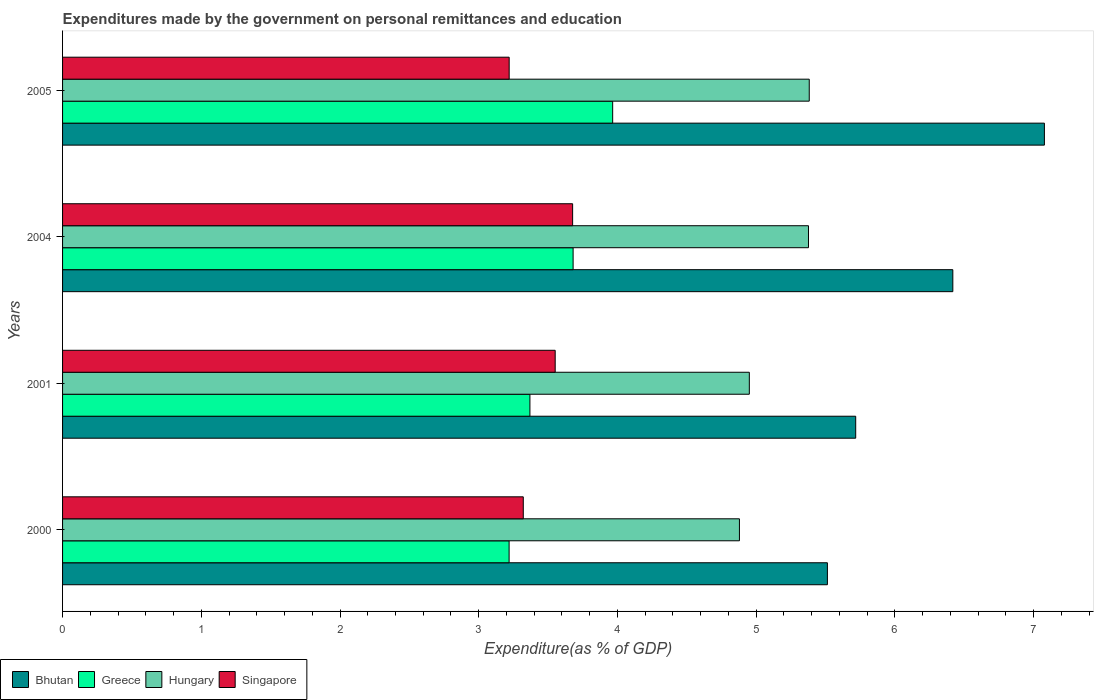How many different coloured bars are there?
Provide a short and direct response. 4. What is the label of the 1st group of bars from the top?
Offer a terse response. 2005. In how many cases, is the number of bars for a given year not equal to the number of legend labels?
Make the answer very short. 0. What is the expenditures made by the government on personal remittances and education in Singapore in 2004?
Give a very brief answer. 3.68. Across all years, what is the maximum expenditures made by the government on personal remittances and education in Greece?
Ensure brevity in your answer.  3.97. Across all years, what is the minimum expenditures made by the government on personal remittances and education in Greece?
Offer a terse response. 3.22. In which year was the expenditures made by the government on personal remittances and education in Singapore maximum?
Make the answer very short. 2004. In which year was the expenditures made by the government on personal remittances and education in Bhutan minimum?
Offer a very short reply. 2000. What is the total expenditures made by the government on personal remittances and education in Hungary in the graph?
Your answer should be compact. 20.59. What is the difference between the expenditures made by the government on personal remittances and education in Hungary in 2000 and that in 2005?
Offer a terse response. -0.5. What is the difference between the expenditures made by the government on personal remittances and education in Singapore in 2004 and the expenditures made by the government on personal remittances and education in Hungary in 2005?
Provide a short and direct response. -1.71. What is the average expenditures made by the government on personal remittances and education in Hungary per year?
Keep it short and to the point. 5.15. In the year 2000, what is the difference between the expenditures made by the government on personal remittances and education in Bhutan and expenditures made by the government on personal remittances and education in Greece?
Provide a short and direct response. 2.29. What is the ratio of the expenditures made by the government on personal remittances and education in Hungary in 2000 to that in 2005?
Provide a succinct answer. 0.91. Is the expenditures made by the government on personal remittances and education in Singapore in 2004 less than that in 2005?
Your answer should be compact. No. Is the difference between the expenditures made by the government on personal remittances and education in Bhutan in 2004 and 2005 greater than the difference between the expenditures made by the government on personal remittances and education in Greece in 2004 and 2005?
Make the answer very short. No. What is the difference between the highest and the second highest expenditures made by the government on personal remittances and education in Greece?
Your response must be concise. 0.29. What is the difference between the highest and the lowest expenditures made by the government on personal remittances and education in Greece?
Make the answer very short. 0.75. Is the sum of the expenditures made by the government on personal remittances and education in Singapore in 2000 and 2005 greater than the maximum expenditures made by the government on personal remittances and education in Bhutan across all years?
Offer a very short reply. No. What does the 2nd bar from the top in 2000 represents?
Make the answer very short. Hungary. What does the 1st bar from the bottom in 2005 represents?
Keep it short and to the point. Bhutan. Is it the case that in every year, the sum of the expenditures made by the government on personal remittances and education in Greece and expenditures made by the government on personal remittances and education in Hungary is greater than the expenditures made by the government on personal remittances and education in Bhutan?
Provide a short and direct response. Yes. Are all the bars in the graph horizontal?
Ensure brevity in your answer.  Yes. What is the difference between two consecutive major ticks on the X-axis?
Make the answer very short. 1. Are the values on the major ticks of X-axis written in scientific E-notation?
Offer a very short reply. No. Does the graph contain any zero values?
Make the answer very short. No. Where does the legend appear in the graph?
Ensure brevity in your answer.  Bottom left. What is the title of the graph?
Provide a succinct answer. Expenditures made by the government on personal remittances and education. What is the label or title of the X-axis?
Offer a terse response. Expenditure(as % of GDP). What is the label or title of the Y-axis?
Your answer should be very brief. Years. What is the Expenditure(as % of GDP) in Bhutan in 2000?
Give a very brief answer. 5.51. What is the Expenditure(as % of GDP) of Greece in 2000?
Keep it short and to the point. 3.22. What is the Expenditure(as % of GDP) of Hungary in 2000?
Give a very brief answer. 4.88. What is the Expenditure(as % of GDP) in Singapore in 2000?
Offer a very short reply. 3.32. What is the Expenditure(as % of GDP) in Bhutan in 2001?
Provide a short and direct response. 5.72. What is the Expenditure(as % of GDP) of Greece in 2001?
Offer a very short reply. 3.37. What is the Expenditure(as % of GDP) of Hungary in 2001?
Provide a short and direct response. 4.95. What is the Expenditure(as % of GDP) of Singapore in 2001?
Your answer should be compact. 3.55. What is the Expenditure(as % of GDP) of Bhutan in 2004?
Offer a very short reply. 6.42. What is the Expenditure(as % of GDP) of Greece in 2004?
Provide a short and direct response. 3.68. What is the Expenditure(as % of GDP) in Hungary in 2004?
Your answer should be compact. 5.38. What is the Expenditure(as % of GDP) of Singapore in 2004?
Keep it short and to the point. 3.68. What is the Expenditure(as % of GDP) in Bhutan in 2005?
Offer a terse response. 7.08. What is the Expenditure(as % of GDP) of Greece in 2005?
Provide a short and direct response. 3.97. What is the Expenditure(as % of GDP) of Hungary in 2005?
Give a very brief answer. 5.38. What is the Expenditure(as % of GDP) in Singapore in 2005?
Offer a very short reply. 3.22. Across all years, what is the maximum Expenditure(as % of GDP) in Bhutan?
Provide a short and direct response. 7.08. Across all years, what is the maximum Expenditure(as % of GDP) of Greece?
Offer a very short reply. 3.97. Across all years, what is the maximum Expenditure(as % of GDP) in Hungary?
Your answer should be very brief. 5.38. Across all years, what is the maximum Expenditure(as % of GDP) of Singapore?
Provide a succinct answer. 3.68. Across all years, what is the minimum Expenditure(as % of GDP) of Bhutan?
Ensure brevity in your answer.  5.51. Across all years, what is the minimum Expenditure(as % of GDP) in Greece?
Your answer should be compact. 3.22. Across all years, what is the minimum Expenditure(as % of GDP) of Hungary?
Your response must be concise. 4.88. Across all years, what is the minimum Expenditure(as % of GDP) of Singapore?
Ensure brevity in your answer.  3.22. What is the total Expenditure(as % of GDP) of Bhutan in the graph?
Your response must be concise. 24.73. What is the total Expenditure(as % of GDP) of Greece in the graph?
Your answer should be very brief. 14.23. What is the total Expenditure(as % of GDP) of Hungary in the graph?
Ensure brevity in your answer.  20.59. What is the total Expenditure(as % of GDP) of Singapore in the graph?
Offer a very short reply. 13.77. What is the difference between the Expenditure(as % of GDP) of Bhutan in 2000 and that in 2001?
Provide a succinct answer. -0.2. What is the difference between the Expenditure(as % of GDP) of Hungary in 2000 and that in 2001?
Offer a terse response. -0.07. What is the difference between the Expenditure(as % of GDP) of Singapore in 2000 and that in 2001?
Make the answer very short. -0.23. What is the difference between the Expenditure(as % of GDP) of Bhutan in 2000 and that in 2004?
Your answer should be very brief. -0.9. What is the difference between the Expenditure(as % of GDP) in Greece in 2000 and that in 2004?
Make the answer very short. -0.46. What is the difference between the Expenditure(as % of GDP) of Hungary in 2000 and that in 2004?
Ensure brevity in your answer.  -0.5. What is the difference between the Expenditure(as % of GDP) in Singapore in 2000 and that in 2004?
Provide a succinct answer. -0.36. What is the difference between the Expenditure(as % of GDP) in Bhutan in 2000 and that in 2005?
Your response must be concise. -1.56. What is the difference between the Expenditure(as % of GDP) in Greece in 2000 and that in 2005?
Provide a short and direct response. -0.75. What is the difference between the Expenditure(as % of GDP) of Hungary in 2000 and that in 2005?
Your answer should be very brief. -0.5. What is the difference between the Expenditure(as % of GDP) of Singapore in 2000 and that in 2005?
Offer a very short reply. 0.1. What is the difference between the Expenditure(as % of GDP) of Bhutan in 2001 and that in 2004?
Offer a very short reply. -0.7. What is the difference between the Expenditure(as % of GDP) of Greece in 2001 and that in 2004?
Offer a terse response. -0.31. What is the difference between the Expenditure(as % of GDP) in Hungary in 2001 and that in 2004?
Offer a very short reply. -0.43. What is the difference between the Expenditure(as % of GDP) of Singapore in 2001 and that in 2004?
Provide a short and direct response. -0.13. What is the difference between the Expenditure(as % of GDP) of Bhutan in 2001 and that in 2005?
Your answer should be very brief. -1.36. What is the difference between the Expenditure(as % of GDP) in Greece in 2001 and that in 2005?
Your answer should be very brief. -0.6. What is the difference between the Expenditure(as % of GDP) of Hungary in 2001 and that in 2005?
Your answer should be compact. -0.43. What is the difference between the Expenditure(as % of GDP) of Singapore in 2001 and that in 2005?
Give a very brief answer. 0.33. What is the difference between the Expenditure(as % of GDP) of Bhutan in 2004 and that in 2005?
Your answer should be compact. -0.66. What is the difference between the Expenditure(as % of GDP) in Greece in 2004 and that in 2005?
Your answer should be very brief. -0.29. What is the difference between the Expenditure(as % of GDP) of Hungary in 2004 and that in 2005?
Provide a succinct answer. -0.01. What is the difference between the Expenditure(as % of GDP) of Singapore in 2004 and that in 2005?
Keep it short and to the point. 0.46. What is the difference between the Expenditure(as % of GDP) of Bhutan in 2000 and the Expenditure(as % of GDP) of Greece in 2001?
Provide a short and direct response. 2.14. What is the difference between the Expenditure(as % of GDP) of Bhutan in 2000 and the Expenditure(as % of GDP) of Hungary in 2001?
Your answer should be compact. 0.56. What is the difference between the Expenditure(as % of GDP) of Bhutan in 2000 and the Expenditure(as % of GDP) of Singapore in 2001?
Offer a very short reply. 1.96. What is the difference between the Expenditure(as % of GDP) in Greece in 2000 and the Expenditure(as % of GDP) in Hungary in 2001?
Your answer should be compact. -1.73. What is the difference between the Expenditure(as % of GDP) of Greece in 2000 and the Expenditure(as % of GDP) of Singapore in 2001?
Offer a terse response. -0.33. What is the difference between the Expenditure(as % of GDP) in Hungary in 2000 and the Expenditure(as % of GDP) in Singapore in 2001?
Provide a succinct answer. 1.33. What is the difference between the Expenditure(as % of GDP) in Bhutan in 2000 and the Expenditure(as % of GDP) in Greece in 2004?
Provide a succinct answer. 1.83. What is the difference between the Expenditure(as % of GDP) in Bhutan in 2000 and the Expenditure(as % of GDP) in Hungary in 2004?
Provide a succinct answer. 0.14. What is the difference between the Expenditure(as % of GDP) of Bhutan in 2000 and the Expenditure(as % of GDP) of Singapore in 2004?
Your response must be concise. 1.84. What is the difference between the Expenditure(as % of GDP) of Greece in 2000 and the Expenditure(as % of GDP) of Hungary in 2004?
Make the answer very short. -2.16. What is the difference between the Expenditure(as % of GDP) in Greece in 2000 and the Expenditure(as % of GDP) in Singapore in 2004?
Make the answer very short. -0.46. What is the difference between the Expenditure(as % of GDP) of Hungary in 2000 and the Expenditure(as % of GDP) of Singapore in 2004?
Keep it short and to the point. 1.2. What is the difference between the Expenditure(as % of GDP) of Bhutan in 2000 and the Expenditure(as % of GDP) of Greece in 2005?
Your answer should be compact. 1.55. What is the difference between the Expenditure(as % of GDP) in Bhutan in 2000 and the Expenditure(as % of GDP) in Hungary in 2005?
Your response must be concise. 0.13. What is the difference between the Expenditure(as % of GDP) of Bhutan in 2000 and the Expenditure(as % of GDP) of Singapore in 2005?
Provide a short and direct response. 2.29. What is the difference between the Expenditure(as % of GDP) in Greece in 2000 and the Expenditure(as % of GDP) in Hungary in 2005?
Make the answer very short. -2.16. What is the difference between the Expenditure(as % of GDP) of Greece in 2000 and the Expenditure(as % of GDP) of Singapore in 2005?
Provide a succinct answer. -0. What is the difference between the Expenditure(as % of GDP) in Hungary in 2000 and the Expenditure(as % of GDP) in Singapore in 2005?
Your answer should be compact. 1.66. What is the difference between the Expenditure(as % of GDP) in Bhutan in 2001 and the Expenditure(as % of GDP) in Greece in 2004?
Ensure brevity in your answer.  2.04. What is the difference between the Expenditure(as % of GDP) in Bhutan in 2001 and the Expenditure(as % of GDP) in Hungary in 2004?
Provide a succinct answer. 0.34. What is the difference between the Expenditure(as % of GDP) in Bhutan in 2001 and the Expenditure(as % of GDP) in Singapore in 2004?
Make the answer very short. 2.04. What is the difference between the Expenditure(as % of GDP) in Greece in 2001 and the Expenditure(as % of GDP) in Hungary in 2004?
Provide a short and direct response. -2.01. What is the difference between the Expenditure(as % of GDP) in Greece in 2001 and the Expenditure(as % of GDP) in Singapore in 2004?
Give a very brief answer. -0.31. What is the difference between the Expenditure(as % of GDP) in Hungary in 2001 and the Expenditure(as % of GDP) in Singapore in 2004?
Offer a very short reply. 1.27. What is the difference between the Expenditure(as % of GDP) of Bhutan in 2001 and the Expenditure(as % of GDP) of Greece in 2005?
Provide a succinct answer. 1.75. What is the difference between the Expenditure(as % of GDP) of Bhutan in 2001 and the Expenditure(as % of GDP) of Hungary in 2005?
Offer a very short reply. 0.33. What is the difference between the Expenditure(as % of GDP) of Bhutan in 2001 and the Expenditure(as % of GDP) of Singapore in 2005?
Your answer should be compact. 2.5. What is the difference between the Expenditure(as % of GDP) in Greece in 2001 and the Expenditure(as % of GDP) in Hungary in 2005?
Your response must be concise. -2.01. What is the difference between the Expenditure(as % of GDP) of Greece in 2001 and the Expenditure(as % of GDP) of Singapore in 2005?
Keep it short and to the point. 0.15. What is the difference between the Expenditure(as % of GDP) of Hungary in 2001 and the Expenditure(as % of GDP) of Singapore in 2005?
Provide a succinct answer. 1.73. What is the difference between the Expenditure(as % of GDP) of Bhutan in 2004 and the Expenditure(as % of GDP) of Greece in 2005?
Your response must be concise. 2.45. What is the difference between the Expenditure(as % of GDP) of Bhutan in 2004 and the Expenditure(as % of GDP) of Hungary in 2005?
Offer a very short reply. 1.04. What is the difference between the Expenditure(as % of GDP) of Bhutan in 2004 and the Expenditure(as % of GDP) of Singapore in 2005?
Your answer should be compact. 3.2. What is the difference between the Expenditure(as % of GDP) of Greece in 2004 and the Expenditure(as % of GDP) of Hungary in 2005?
Offer a terse response. -1.7. What is the difference between the Expenditure(as % of GDP) in Greece in 2004 and the Expenditure(as % of GDP) in Singapore in 2005?
Give a very brief answer. 0.46. What is the difference between the Expenditure(as % of GDP) in Hungary in 2004 and the Expenditure(as % of GDP) in Singapore in 2005?
Give a very brief answer. 2.16. What is the average Expenditure(as % of GDP) in Bhutan per year?
Keep it short and to the point. 6.18. What is the average Expenditure(as % of GDP) in Greece per year?
Your answer should be very brief. 3.56. What is the average Expenditure(as % of GDP) of Hungary per year?
Offer a very short reply. 5.15. What is the average Expenditure(as % of GDP) in Singapore per year?
Offer a terse response. 3.44. In the year 2000, what is the difference between the Expenditure(as % of GDP) of Bhutan and Expenditure(as % of GDP) of Greece?
Keep it short and to the point. 2.29. In the year 2000, what is the difference between the Expenditure(as % of GDP) in Bhutan and Expenditure(as % of GDP) in Hungary?
Make the answer very short. 0.63. In the year 2000, what is the difference between the Expenditure(as % of GDP) in Bhutan and Expenditure(as % of GDP) in Singapore?
Offer a terse response. 2.19. In the year 2000, what is the difference between the Expenditure(as % of GDP) of Greece and Expenditure(as % of GDP) of Hungary?
Your answer should be very brief. -1.66. In the year 2000, what is the difference between the Expenditure(as % of GDP) of Greece and Expenditure(as % of GDP) of Singapore?
Offer a terse response. -0.1. In the year 2000, what is the difference between the Expenditure(as % of GDP) of Hungary and Expenditure(as % of GDP) of Singapore?
Make the answer very short. 1.56. In the year 2001, what is the difference between the Expenditure(as % of GDP) of Bhutan and Expenditure(as % of GDP) of Greece?
Ensure brevity in your answer.  2.35. In the year 2001, what is the difference between the Expenditure(as % of GDP) of Bhutan and Expenditure(as % of GDP) of Hungary?
Offer a terse response. 0.77. In the year 2001, what is the difference between the Expenditure(as % of GDP) of Bhutan and Expenditure(as % of GDP) of Singapore?
Provide a succinct answer. 2.17. In the year 2001, what is the difference between the Expenditure(as % of GDP) in Greece and Expenditure(as % of GDP) in Hungary?
Give a very brief answer. -1.58. In the year 2001, what is the difference between the Expenditure(as % of GDP) of Greece and Expenditure(as % of GDP) of Singapore?
Make the answer very short. -0.18. In the year 2001, what is the difference between the Expenditure(as % of GDP) of Hungary and Expenditure(as % of GDP) of Singapore?
Make the answer very short. 1.4. In the year 2004, what is the difference between the Expenditure(as % of GDP) in Bhutan and Expenditure(as % of GDP) in Greece?
Your answer should be compact. 2.74. In the year 2004, what is the difference between the Expenditure(as % of GDP) in Bhutan and Expenditure(as % of GDP) in Hungary?
Your answer should be very brief. 1.04. In the year 2004, what is the difference between the Expenditure(as % of GDP) in Bhutan and Expenditure(as % of GDP) in Singapore?
Your answer should be very brief. 2.74. In the year 2004, what is the difference between the Expenditure(as % of GDP) of Greece and Expenditure(as % of GDP) of Hungary?
Provide a succinct answer. -1.7. In the year 2004, what is the difference between the Expenditure(as % of GDP) of Greece and Expenditure(as % of GDP) of Singapore?
Provide a succinct answer. 0. In the year 2004, what is the difference between the Expenditure(as % of GDP) of Hungary and Expenditure(as % of GDP) of Singapore?
Provide a succinct answer. 1.7. In the year 2005, what is the difference between the Expenditure(as % of GDP) in Bhutan and Expenditure(as % of GDP) in Greece?
Your answer should be compact. 3.11. In the year 2005, what is the difference between the Expenditure(as % of GDP) of Bhutan and Expenditure(as % of GDP) of Hungary?
Offer a very short reply. 1.7. In the year 2005, what is the difference between the Expenditure(as % of GDP) in Bhutan and Expenditure(as % of GDP) in Singapore?
Your response must be concise. 3.86. In the year 2005, what is the difference between the Expenditure(as % of GDP) of Greece and Expenditure(as % of GDP) of Hungary?
Offer a terse response. -1.42. In the year 2005, what is the difference between the Expenditure(as % of GDP) of Greece and Expenditure(as % of GDP) of Singapore?
Make the answer very short. 0.75. In the year 2005, what is the difference between the Expenditure(as % of GDP) of Hungary and Expenditure(as % of GDP) of Singapore?
Offer a very short reply. 2.16. What is the ratio of the Expenditure(as % of GDP) of Greece in 2000 to that in 2001?
Give a very brief answer. 0.96. What is the ratio of the Expenditure(as % of GDP) of Hungary in 2000 to that in 2001?
Make the answer very short. 0.99. What is the ratio of the Expenditure(as % of GDP) of Singapore in 2000 to that in 2001?
Your answer should be very brief. 0.94. What is the ratio of the Expenditure(as % of GDP) of Bhutan in 2000 to that in 2004?
Your answer should be compact. 0.86. What is the ratio of the Expenditure(as % of GDP) in Greece in 2000 to that in 2004?
Your response must be concise. 0.87. What is the ratio of the Expenditure(as % of GDP) of Hungary in 2000 to that in 2004?
Your answer should be compact. 0.91. What is the ratio of the Expenditure(as % of GDP) in Singapore in 2000 to that in 2004?
Your answer should be very brief. 0.9. What is the ratio of the Expenditure(as % of GDP) in Bhutan in 2000 to that in 2005?
Ensure brevity in your answer.  0.78. What is the ratio of the Expenditure(as % of GDP) of Greece in 2000 to that in 2005?
Your response must be concise. 0.81. What is the ratio of the Expenditure(as % of GDP) of Hungary in 2000 to that in 2005?
Provide a succinct answer. 0.91. What is the ratio of the Expenditure(as % of GDP) in Singapore in 2000 to that in 2005?
Offer a very short reply. 1.03. What is the ratio of the Expenditure(as % of GDP) in Bhutan in 2001 to that in 2004?
Offer a terse response. 0.89. What is the ratio of the Expenditure(as % of GDP) in Greece in 2001 to that in 2004?
Your answer should be very brief. 0.92. What is the ratio of the Expenditure(as % of GDP) of Hungary in 2001 to that in 2004?
Offer a terse response. 0.92. What is the ratio of the Expenditure(as % of GDP) in Singapore in 2001 to that in 2004?
Offer a terse response. 0.97. What is the ratio of the Expenditure(as % of GDP) in Bhutan in 2001 to that in 2005?
Offer a very short reply. 0.81. What is the ratio of the Expenditure(as % of GDP) in Greece in 2001 to that in 2005?
Provide a short and direct response. 0.85. What is the ratio of the Expenditure(as % of GDP) in Hungary in 2001 to that in 2005?
Provide a succinct answer. 0.92. What is the ratio of the Expenditure(as % of GDP) in Singapore in 2001 to that in 2005?
Ensure brevity in your answer.  1.1. What is the ratio of the Expenditure(as % of GDP) of Bhutan in 2004 to that in 2005?
Ensure brevity in your answer.  0.91. What is the ratio of the Expenditure(as % of GDP) in Greece in 2004 to that in 2005?
Make the answer very short. 0.93. What is the ratio of the Expenditure(as % of GDP) in Singapore in 2004 to that in 2005?
Offer a very short reply. 1.14. What is the difference between the highest and the second highest Expenditure(as % of GDP) of Bhutan?
Ensure brevity in your answer.  0.66. What is the difference between the highest and the second highest Expenditure(as % of GDP) in Greece?
Make the answer very short. 0.29. What is the difference between the highest and the second highest Expenditure(as % of GDP) in Hungary?
Offer a terse response. 0.01. What is the difference between the highest and the second highest Expenditure(as % of GDP) of Singapore?
Your answer should be very brief. 0.13. What is the difference between the highest and the lowest Expenditure(as % of GDP) in Bhutan?
Give a very brief answer. 1.56. What is the difference between the highest and the lowest Expenditure(as % of GDP) in Greece?
Offer a very short reply. 0.75. What is the difference between the highest and the lowest Expenditure(as % of GDP) in Hungary?
Your answer should be compact. 0.5. What is the difference between the highest and the lowest Expenditure(as % of GDP) of Singapore?
Your answer should be compact. 0.46. 